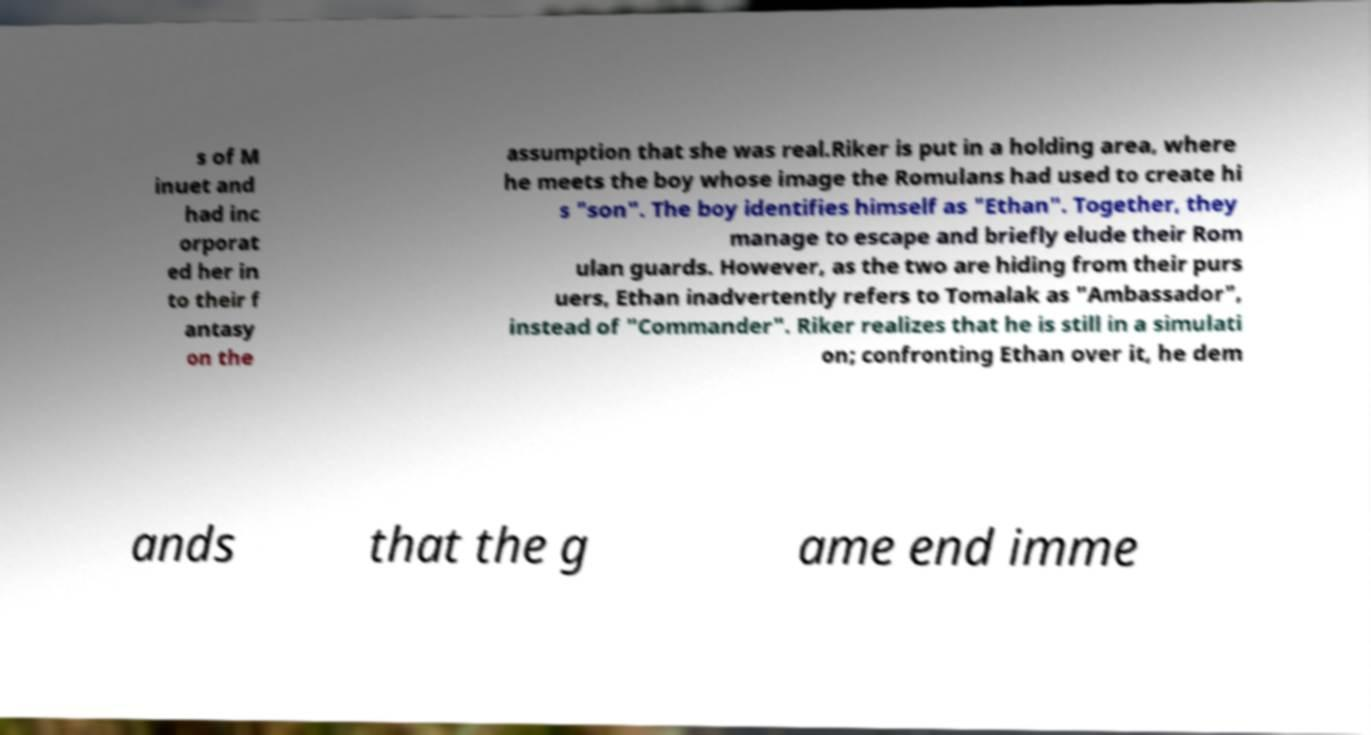Can you accurately transcribe the text from the provided image for me? s of M inuet and had inc orporat ed her in to their f antasy on the assumption that she was real.Riker is put in a holding area, where he meets the boy whose image the Romulans had used to create hi s "son". The boy identifies himself as "Ethan". Together, they manage to escape and briefly elude their Rom ulan guards. However, as the two are hiding from their purs uers, Ethan inadvertently refers to Tomalak as "Ambassador", instead of "Commander". Riker realizes that he is still in a simulati on; confronting Ethan over it, he dem ands that the g ame end imme 